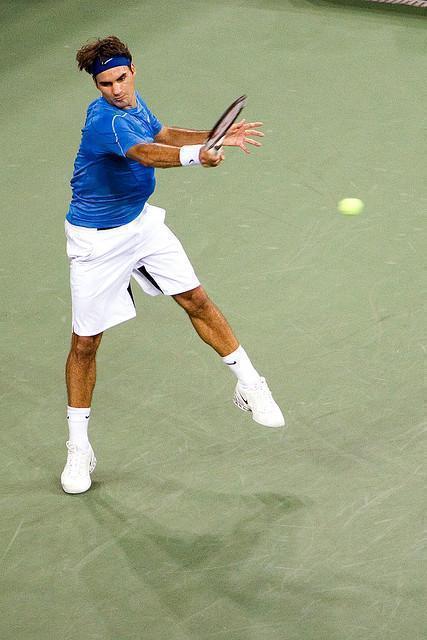What did this tennis player just do?
Select the correct answer and articulate reasoning with the following format: 'Answer: answer
Rationale: rationale.'
Options: Returned ball, lost, quit, served. Answer: returned ball.
Rationale: The players is hitting the green ball back. 